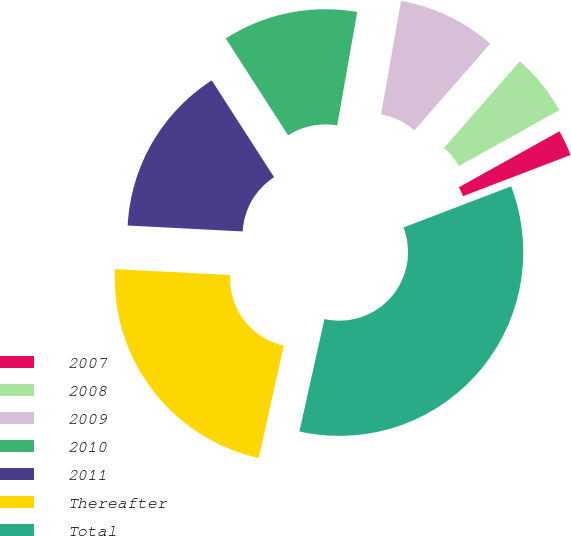<chart> <loc_0><loc_0><loc_500><loc_500><pie_chart><fcel>2007<fcel>2008<fcel>2009<fcel>2010<fcel>2011<fcel>Thereafter<fcel>Total<nl><fcel>2.27%<fcel>5.47%<fcel>8.67%<fcel>11.88%<fcel>15.08%<fcel>22.33%<fcel>34.3%<nl></chart> 